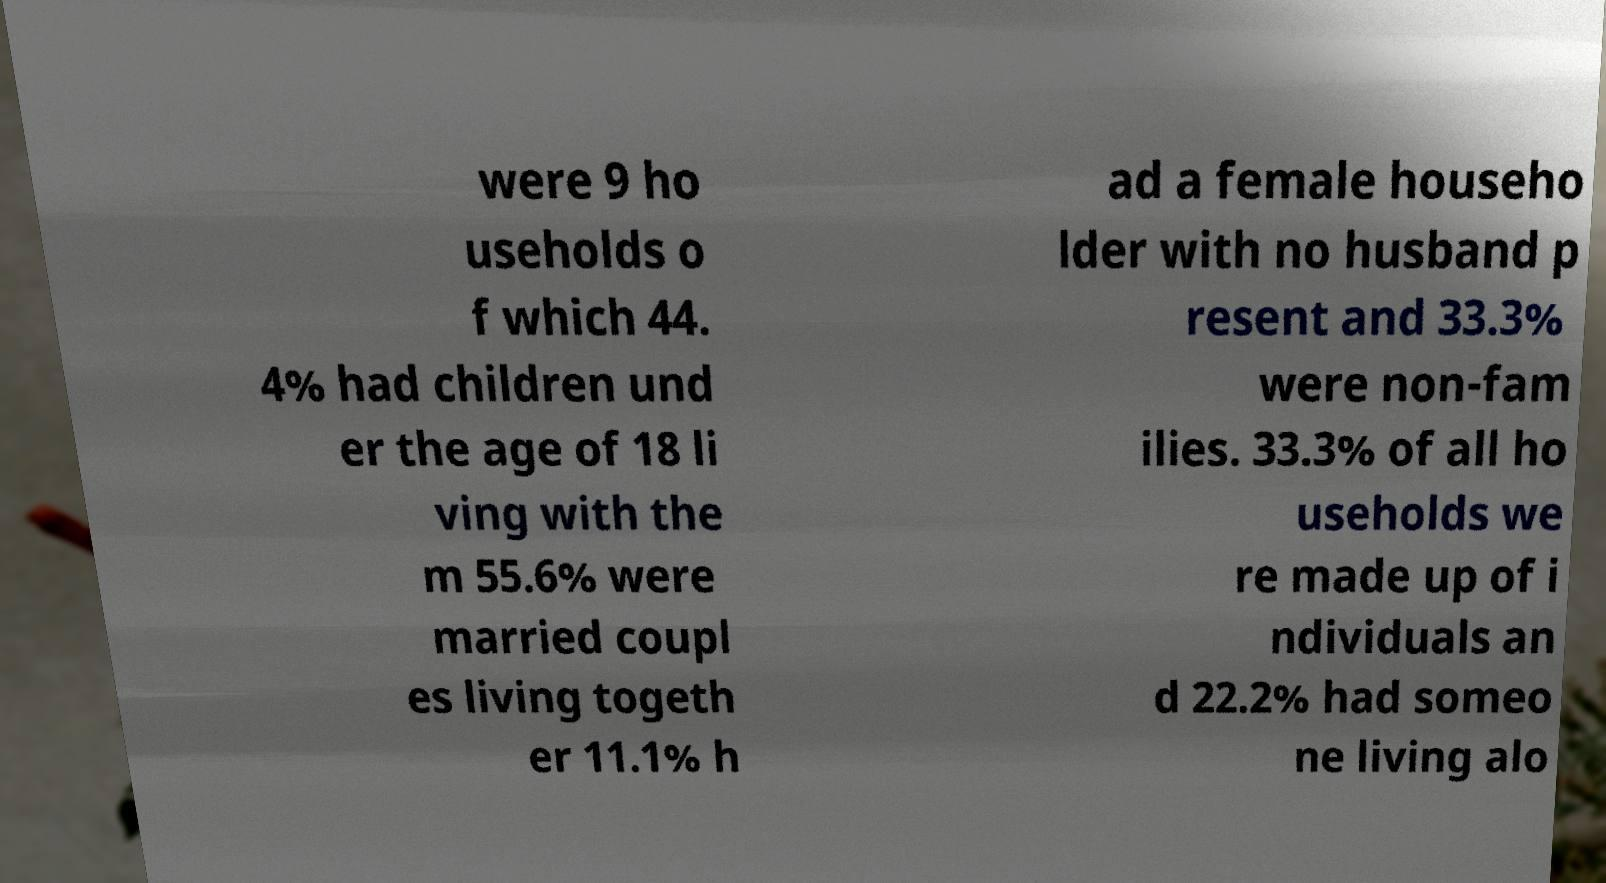Can you accurately transcribe the text from the provided image for me? were 9 ho useholds o f which 44. 4% had children und er the age of 18 li ving with the m 55.6% were married coupl es living togeth er 11.1% h ad a female househo lder with no husband p resent and 33.3% were non-fam ilies. 33.3% of all ho useholds we re made up of i ndividuals an d 22.2% had someo ne living alo 